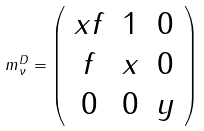<formula> <loc_0><loc_0><loc_500><loc_500>m _ { \nu } ^ { D } = \left ( \begin{array} { c c c } x f & 1 & 0 \\ f & x & 0 \\ 0 & 0 & y \end{array} \right )</formula> 